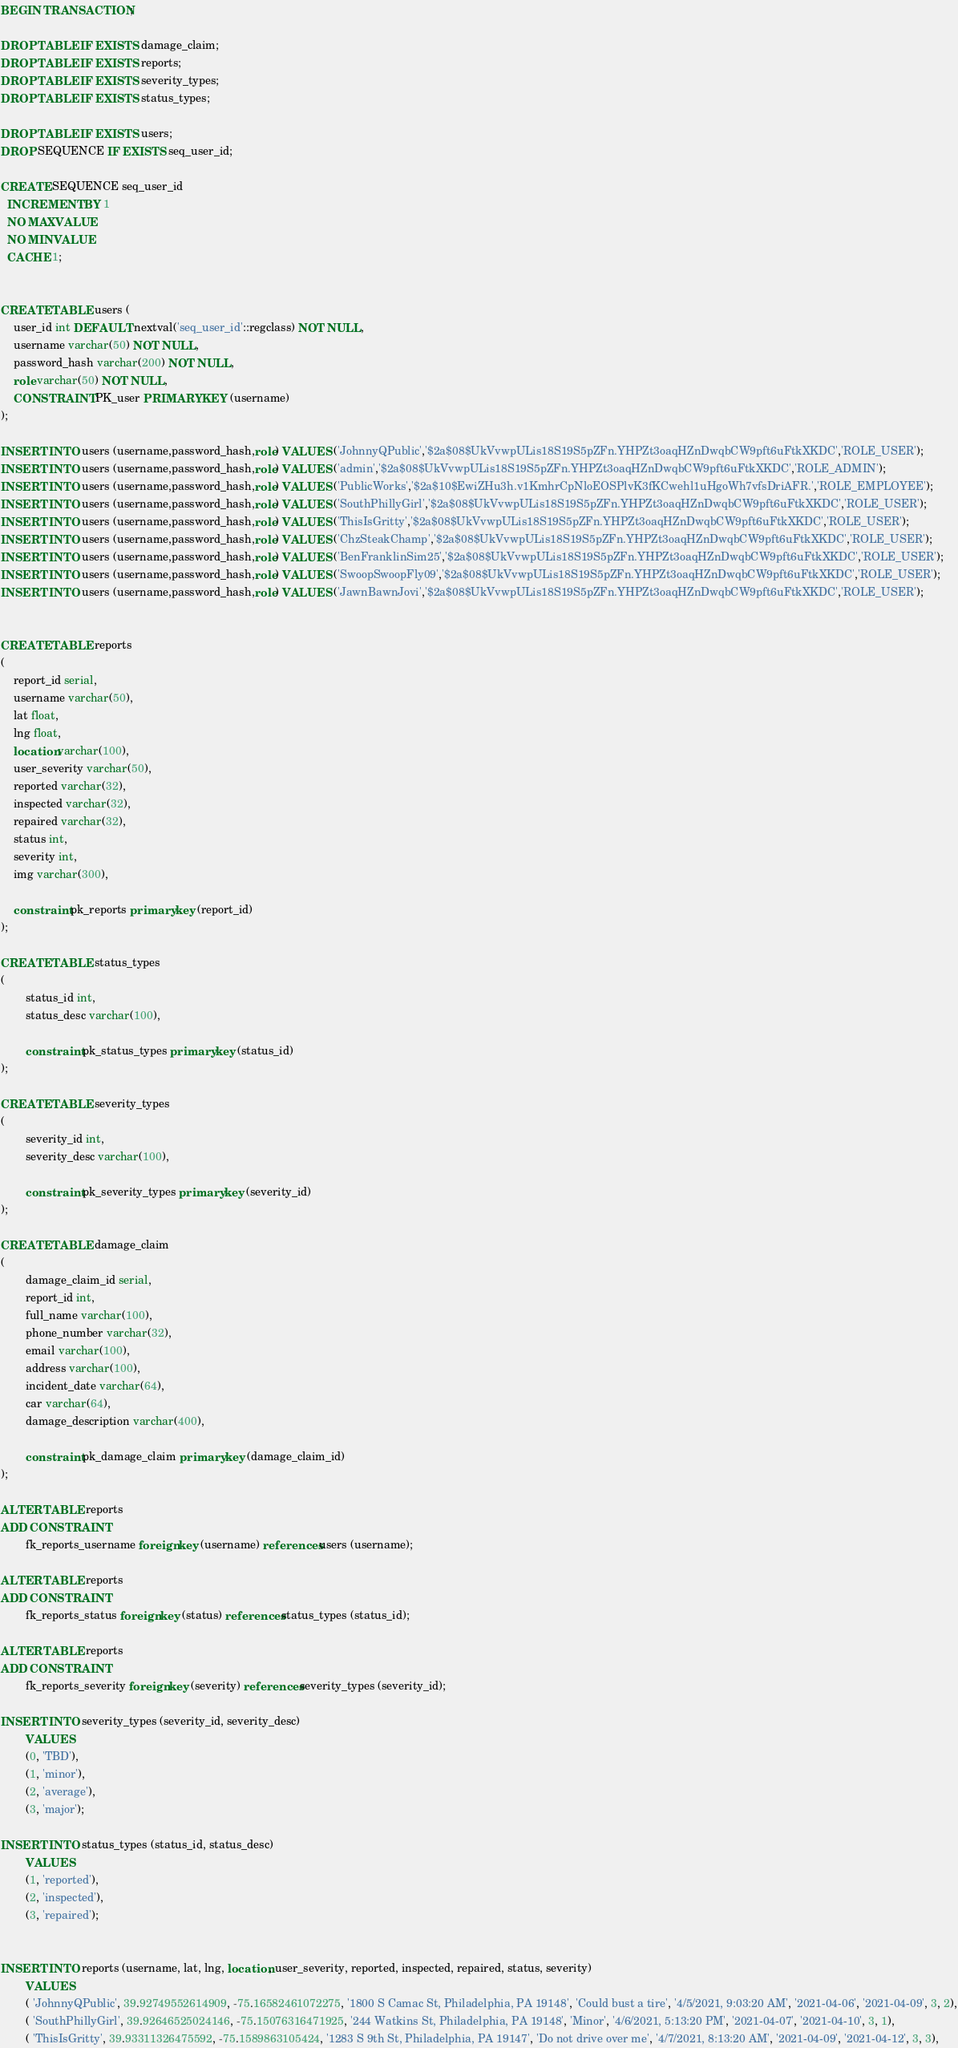<code> <loc_0><loc_0><loc_500><loc_500><_SQL_>BEGIN TRANSACTION;

DROP TABLE IF EXISTS damage_claim;
DROP TABLE IF EXISTS reports;
DROP TABLE IF EXISTS severity_types;
DROP TABLE IF EXISTS status_types;

DROP TABLE IF EXISTS users;
DROP SEQUENCE IF EXISTS seq_user_id;

CREATE SEQUENCE seq_user_id
  INCREMENT BY 1
  NO MAXVALUE
  NO MINVALUE
  CACHE 1;


CREATE TABLE users (
	user_id int DEFAULT nextval('seq_user_id'::regclass) NOT NULL,
	username varchar(50) NOT NULL,
	password_hash varchar(200) NOT NULL,
	role varchar(50) NOT NULL,
	CONSTRAINT PK_user PRIMARY KEY (username)
);

INSERT INTO users (username,password_hash,role) VALUES ('JohnnyQPublic','$2a$08$UkVvwpULis18S19S5pZFn.YHPZt3oaqHZnDwqbCW9pft6uFtkXKDC','ROLE_USER');
INSERT INTO users (username,password_hash,role) VALUES ('admin','$2a$08$UkVvwpULis18S19S5pZFn.YHPZt3oaqHZnDwqbCW9pft6uFtkXKDC','ROLE_ADMIN');
INSERT INTO users (username,password_hash,role) VALUES ('PublicWorks','$2a$10$EwiZHu3h.v1KmhrCpNloEOSPlvK3fKCwehl1uHgoWh7vfsDriAFR.','ROLE_EMPLOYEE');
INSERT INTO users (username,password_hash,role) VALUES ('SouthPhillyGirl','$2a$08$UkVvwpULis18S19S5pZFn.YHPZt3oaqHZnDwqbCW9pft6uFtkXKDC','ROLE_USER');
INSERT INTO users (username,password_hash,role) VALUES ('ThisIsGritty','$2a$08$UkVvwpULis18S19S5pZFn.YHPZt3oaqHZnDwqbCW9pft6uFtkXKDC','ROLE_USER');
INSERT INTO users (username,password_hash,role) VALUES ('ChzSteakChamp','$2a$08$UkVvwpULis18S19S5pZFn.YHPZt3oaqHZnDwqbCW9pft6uFtkXKDC','ROLE_USER');
INSERT INTO users (username,password_hash,role) VALUES ('BenFranklinSim25','$2a$08$UkVvwpULis18S19S5pZFn.YHPZt3oaqHZnDwqbCW9pft6uFtkXKDC','ROLE_USER');
INSERT INTO users (username,password_hash,role) VALUES ('SwoopSwoopFly09','$2a$08$UkVvwpULis18S19S5pZFn.YHPZt3oaqHZnDwqbCW9pft6uFtkXKDC','ROLE_USER');
INSERT INTO users (username,password_hash,role) VALUES ('JawnBawnJovi','$2a$08$UkVvwpULis18S19S5pZFn.YHPZt3oaqHZnDwqbCW9pft6uFtkXKDC','ROLE_USER');


CREATE TABLE reports
(
	report_id serial,
	username varchar(50),
	lat float,
	lng float, 
	location varchar(100),
	user_severity varchar(50),
	reported varchar(32),
	inspected varchar(32),
	repaired varchar(32),
	status int,
	severity int,
	img varchar(300),
	
	constraint pk_reports primary key (report_id)
);

CREATE TABLE status_types
(
        status_id int,
        status_desc varchar(100),
        
        constraint pk_status_types primary key (status_id)
);

CREATE TABLE severity_types
(
        severity_id int,
        severity_desc varchar(100),
        
        constraint pk_severity_types primary key (severity_id)
);

CREATE TABLE damage_claim
(
        damage_claim_id serial,
        report_id int,
        full_name varchar(100),
        phone_number varchar(32), 
        email varchar(100),
        address varchar(100),
        incident_date varchar(64),
        car varchar(64),
        damage_description varchar(400),
        
        constraint pk_damage_claim primary key (damage_claim_id)
);

ALTER TABLE reports
ADD CONSTRAINT
        fk_reports_username foreign key (username) references users (username);

ALTER TABLE reports
ADD CONSTRAINT
        fk_reports_status foreign key (status) references status_types (status_id);
        
ALTER TABLE reports
ADD CONSTRAINT
        fk_reports_severity foreign key (severity) references severity_types (severity_id);
        
INSERT INTO severity_types (severity_id, severity_desc) 
        VALUES 
        (0, 'TBD'),
        (1, 'minor'), 
        (2, 'average'), 
        (3, 'major');
        
INSERT INTO status_types (status_id, status_desc) 
        VALUES 
        (1, 'reported'),
        (2, 'inspected'),
        (3, 'repaired');

     
INSERT INTO reports (username, lat, lng, location, user_severity, reported, inspected, repaired, status, severity) 
        VALUES                                                     
        ( 'JohnnyQPublic', 39.92749552614909, -75.16582461072275, '1800 S Camac St, Philadelphia, PA 19148', 'Could bust a tire', '4/5/2021, 9:03:20 AM', '2021-04-06', '2021-04-09', 3, 2),
        ( 'SouthPhillyGirl', 39.92646525024146, -75.15076316471925, '244 Watkins St, Philadelphia, PA 19148', 'Minor', '4/6/2021, 5:13:20 PM', '2021-04-07', '2021-04-10', 3, 1),
        ( 'ThisIsGritty', 39.93311326475592, -75.1589863105424, '1283 S 9th St, Philadelphia, PA 19147', 'Do not drive over me', '4/7/2021, 8:13:20 AM', '2021-04-09', '2021-04-12', 3, 3),</code> 